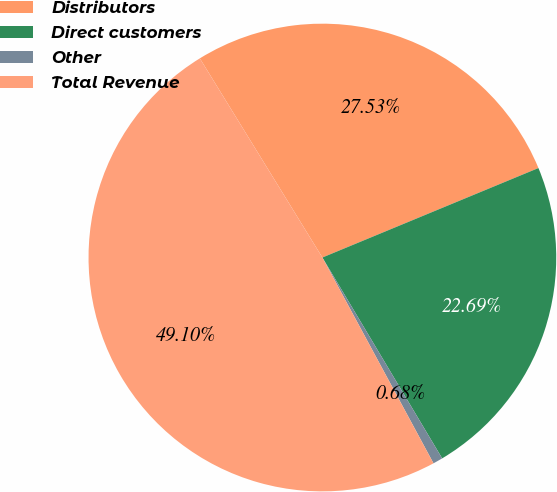<chart> <loc_0><loc_0><loc_500><loc_500><pie_chart><fcel>Distributors<fcel>Direct customers<fcel>Other<fcel>Total Revenue<nl><fcel>27.53%<fcel>22.69%<fcel>0.68%<fcel>49.1%<nl></chart> 